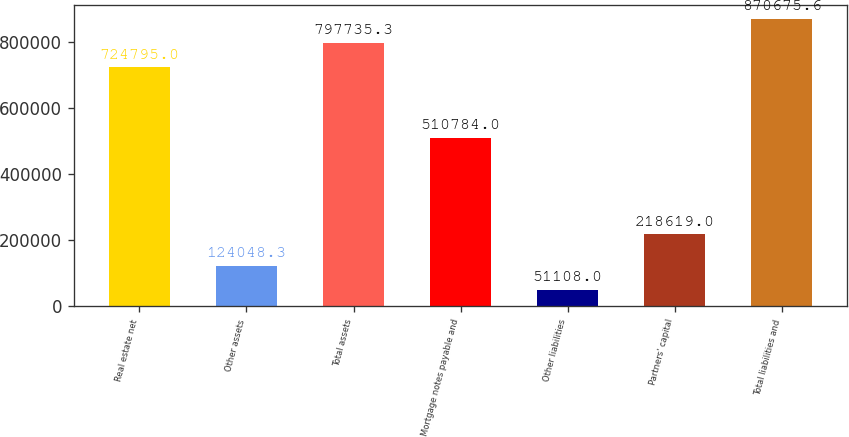<chart> <loc_0><loc_0><loc_500><loc_500><bar_chart><fcel>Real estate net<fcel>Other assets<fcel>Total assets<fcel>Mortgage notes payable and<fcel>Other liabilities<fcel>Partners' capital<fcel>Total liabilities and<nl><fcel>724795<fcel>124048<fcel>797735<fcel>510784<fcel>51108<fcel>218619<fcel>870676<nl></chart> 